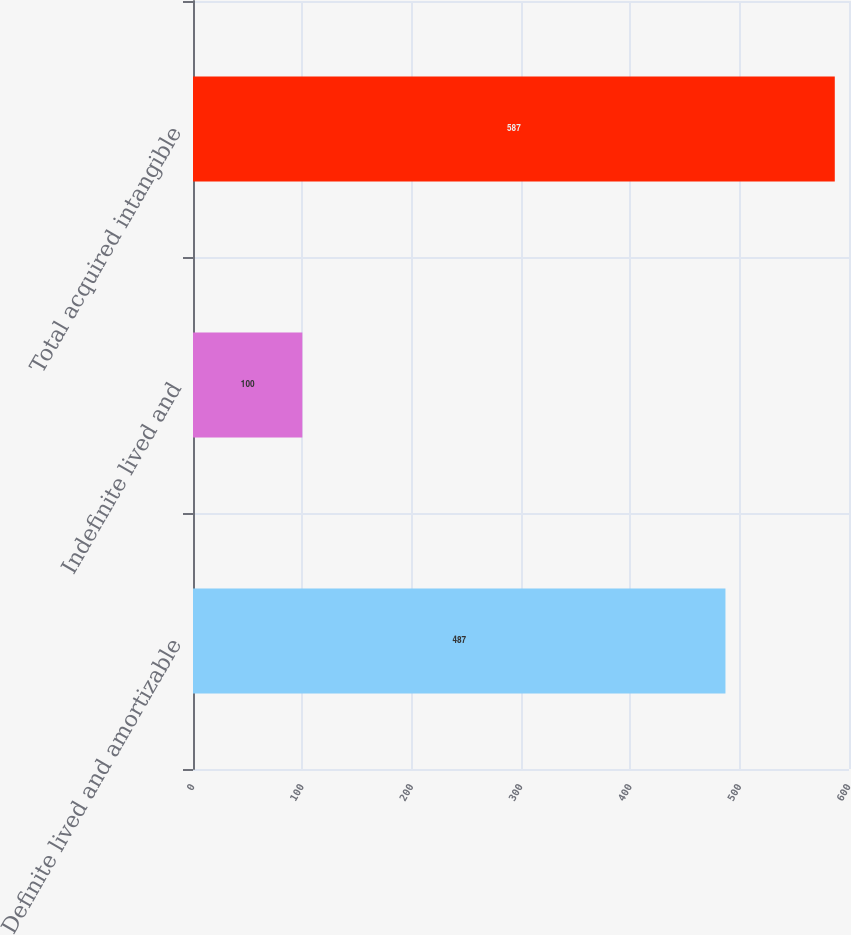Convert chart to OTSL. <chart><loc_0><loc_0><loc_500><loc_500><bar_chart><fcel>Definite lived and amortizable<fcel>Indefinite lived and<fcel>Total acquired intangible<nl><fcel>487<fcel>100<fcel>587<nl></chart> 